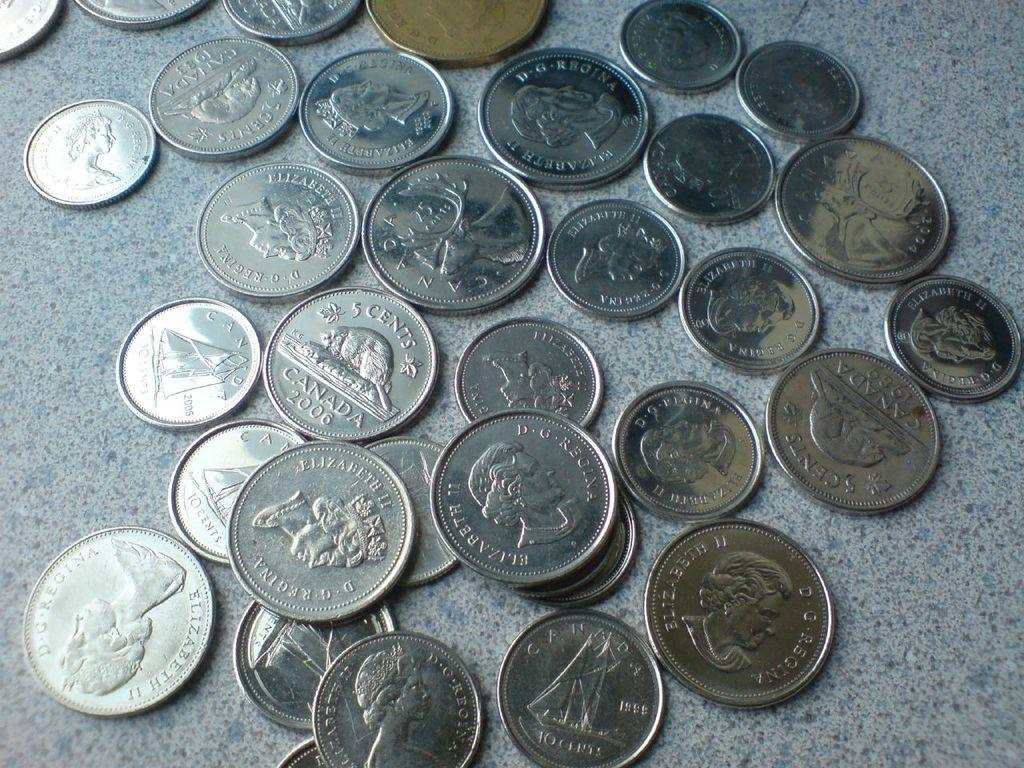<image>
Relay a brief, clear account of the picture shown. a series of silver coins next to each other on a counter with the words '5 cent canada' on some of them 